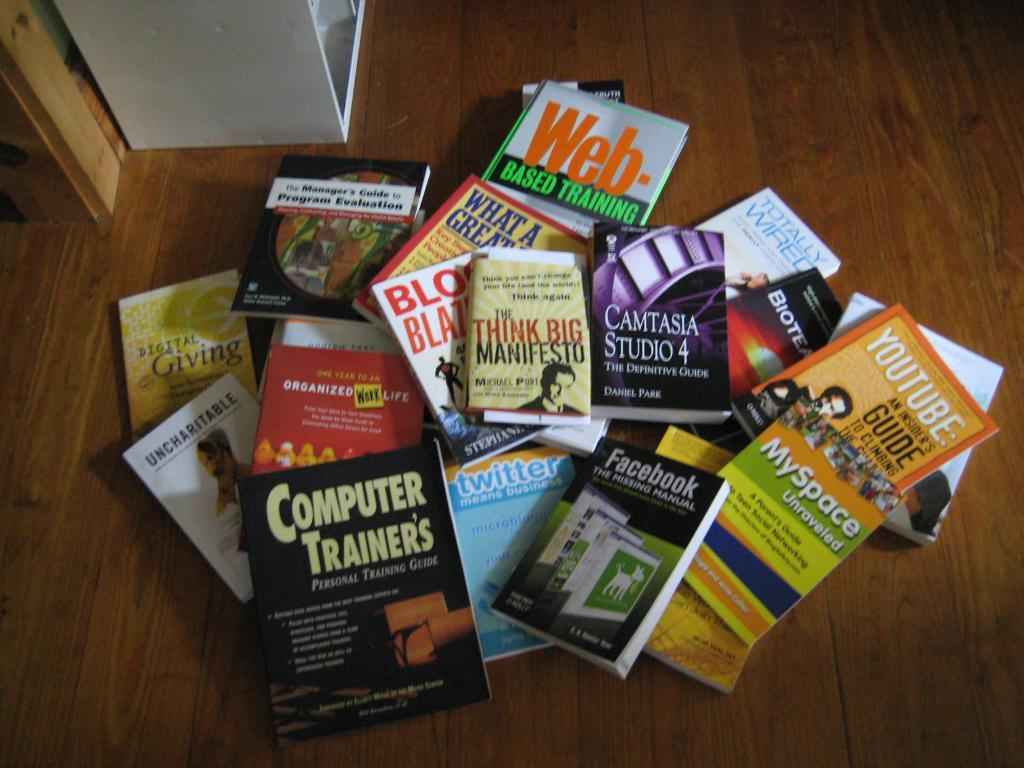<image>
Relay a brief, clear account of the picture shown. A big pile of books on the floor including books on MySpace and YouTube. 